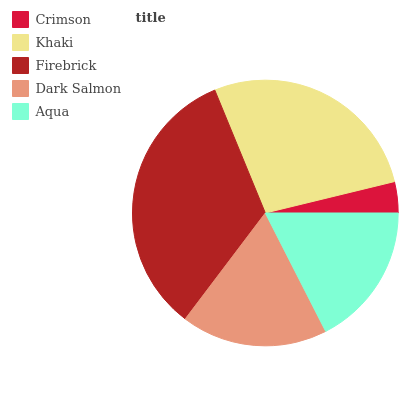Is Crimson the minimum?
Answer yes or no. Yes. Is Firebrick the maximum?
Answer yes or no. Yes. Is Khaki the minimum?
Answer yes or no. No. Is Khaki the maximum?
Answer yes or no. No. Is Khaki greater than Crimson?
Answer yes or no. Yes. Is Crimson less than Khaki?
Answer yes or no. Yes. Is Crimson greater than Khaki?
Answer yes or no. No. Is Khaki less than Crimson?
Answer yes or no. No. Is Dark Salmon the high median?
Answer yes or no. Yes. Is Dark Salmon the low median?
Answer yes or no. Yes. Is Khaki the high median?
Answer yes or no. No. Is Crimson the low median?
Answer yes or no. No. 